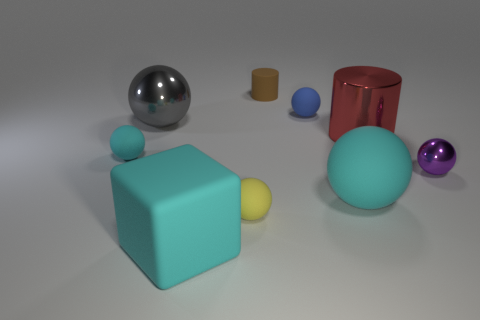There is a small matte ball that is in front of the large matte sphere; is there a big gray metal sphere in front of it?
Your response must be concise. No. What color is the other shiny object that is the same shape as the small brown object?
Your answer should be compact. Red. Is there anything else that has the same shape as the tiny brown rubber thing?
Your response must be concise. Yes. There is another large thing that is made of the same material as the big red thing; what color is it?
Your response must be concise. Gray. Is there a red shiny cylinder behind the cyan rubber ball behind the large ball in front of the small purple thing?
Give a very brief answer. Yes. Is the number of cylinders that are behind the red object less than the number of red metal cylinders to the right of the tiny matte cylinder?
Provide a short and direct response. No. What number of large red objects have the same material as the big cyan sphere?
Your answer should be very brief. 0. Is the size of the blue object the same as the cylinder that is in front of the tiny blue matte sphere?
Provide a succinct answer. No. What material is the tiny thing that is the same color as the cube?
Keep it short and to the point. Rubber. How big is the cylinder behind the big metallic object that is left of the small rubber thing that is in front of the purple metal ball?
Keep it short and to the point. Small. 